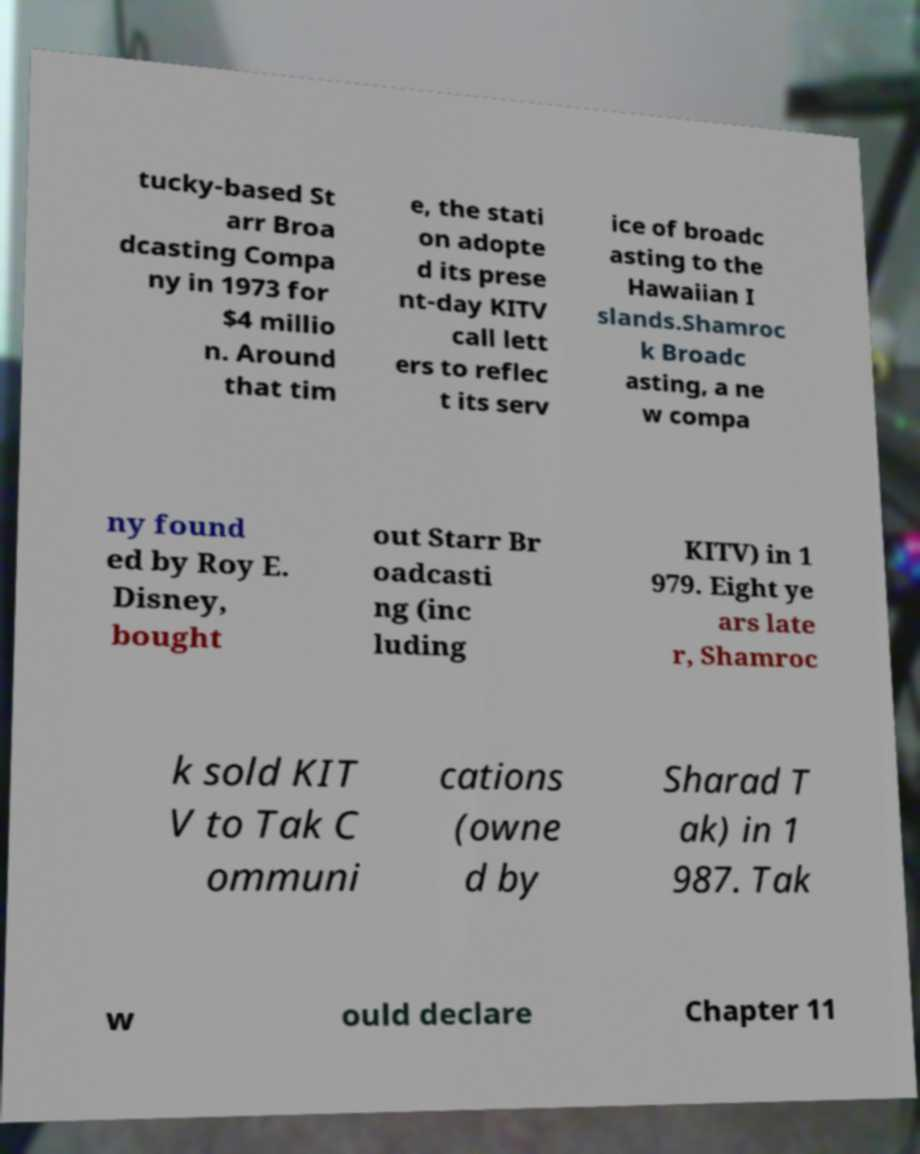Could you assist in decoding the text presented in this image and type it out clearly? tucky-based St arr Broa dcasting Compa ny in 1973 for $4 millio n. Around that tim e, the stati on adopte d its prese nt-day KITV call lett ers to reflec t its serv ice of broadc asting to the Hawaiian I slands.Shamroc k Broadc asting, a ne w compa ny found ed by Roy E. Disney, bought out Starr Br oadcasti ng (inc luding KITV) in 1 979. Eight ye ars late r, Shamroc k sold KIT V to Tak C ommuni cations (owne d by Sharad T ak) in 1 987. Tak w ould declare Chapter 11 